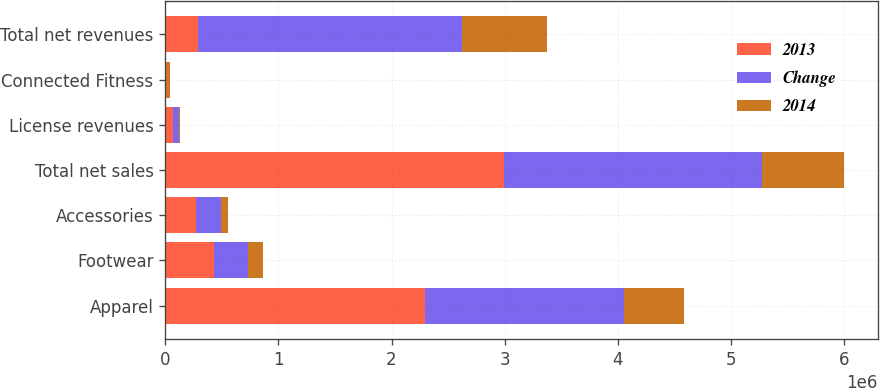Convert chart. <chart><loc_0><loc_0><loc_500><loc_500><stacked_bar_chart><ecel><fcel>Apparel<fcel>Footwear<fcel>Accessories<fcel>Total net sales<fcel>License revenues<fcel>Connected Fitness<fcel>Total net revenues<nl><fcel>2013<fcel>2.29152e+06<fcel>430987<fcel>275409<fcel>2.99792e+06<fcel>67229<fcel>19225<fcel>287117<nl><fcel>Change<fcel>1.76215e+06<fcel>298825<fcel>216098<fcel>2.27707e+06<fcel>53910<fcel>1068<fcel>2.33205e+06<nl><fcel>2014<fcel>529370<fcel>132162<fcel>59311<fcel>720843<fcel>13319<fcel>18157<fcel>752319<nl></chart> 